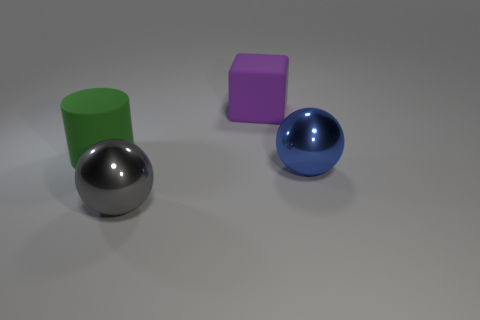What shape is the big object that is the same material as the large blue sphere?
Your answer should be compact. Sphere. Is there anything else that has the same color as the rubber cube?
Offer a very short reply. No. Is the number of gray balls in front of the green cylinder greater than the number of tiny yellow rubber balls?
Ensure brevity in your answer.  Yes. Do the blue object and the rubber object that is left of the purple matte block have the same shape?
Your answer should be compact. No. What number of other rubber things have the same size as the blue thing?
Your response must be concise. 2. There is a ball that is behind the large gray metallic thing in front of the big purple rubber block; how many matte cubes are in front of it?
Your response must be concise. 0. Is the number of big purple things behind the big gray metal ball the same as the number of blue shiny objects that are in front of the large matte cylinder?
Your answer should be very brief. Yes. How many gray metallic objects are the same shape as the big blue metal thing?
Your answer should be very brief. 1. Is there another object that has the same material as the big purple thing?
Give a very brief answer. Yes. How many big purple shiny cylinders are there?
Ensure brevity in your answer.  0. 